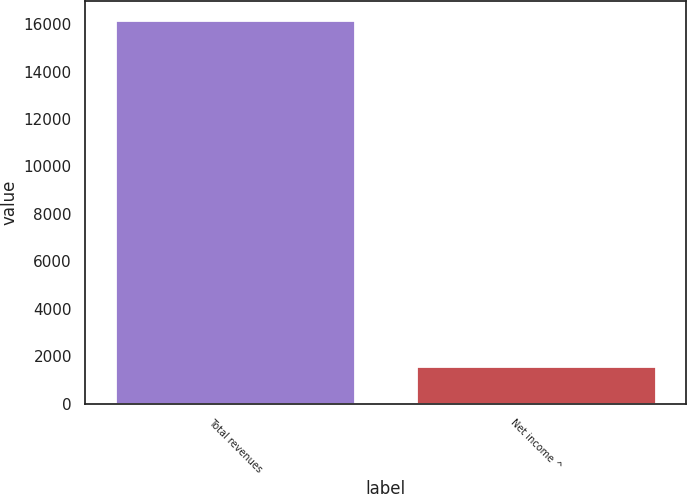Convert chart. <chart><loc_0><loc_0><loc_500><loc_500><bar_chart><fcel>Total revenues<fcel>Net income ^<nl><fcel>16163<fcel>1612<nl></chart> 